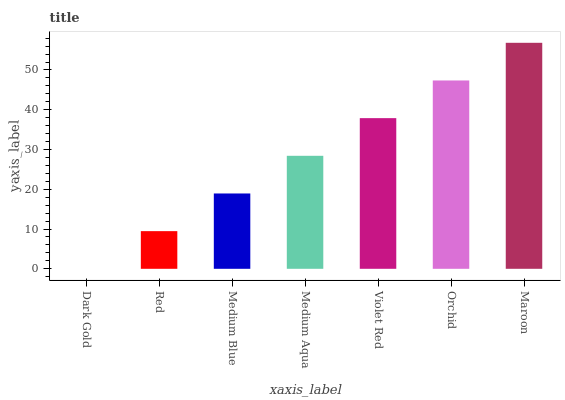Is Dark Gold the minimum?
Answer yes or no. Yes. Is Maroon the maximum?
Answer yes or no. Yes. Is Red the minimum?
Answer yes or no. No. Is Red the maximum?
Answer yes or no. No. Is Red greater than Dark Gold?
Answer yes or no. Yes. Is Dark Gold less than Red?
Answer yes or no. Yes. Is Dark Gold greater than Red?
Answer yes or no. No. Is Red less than Dark Gold?
Answer yes or no. No. Is Medium Aqua the high median?
Answer yes or no. Yes. Is Medium Aqua the low median?
Answer yes or no. Yes. Is Medium Blue the high median?
Answer yes or no. No. Is Orchid the low median?
Answer yes or no. No. 